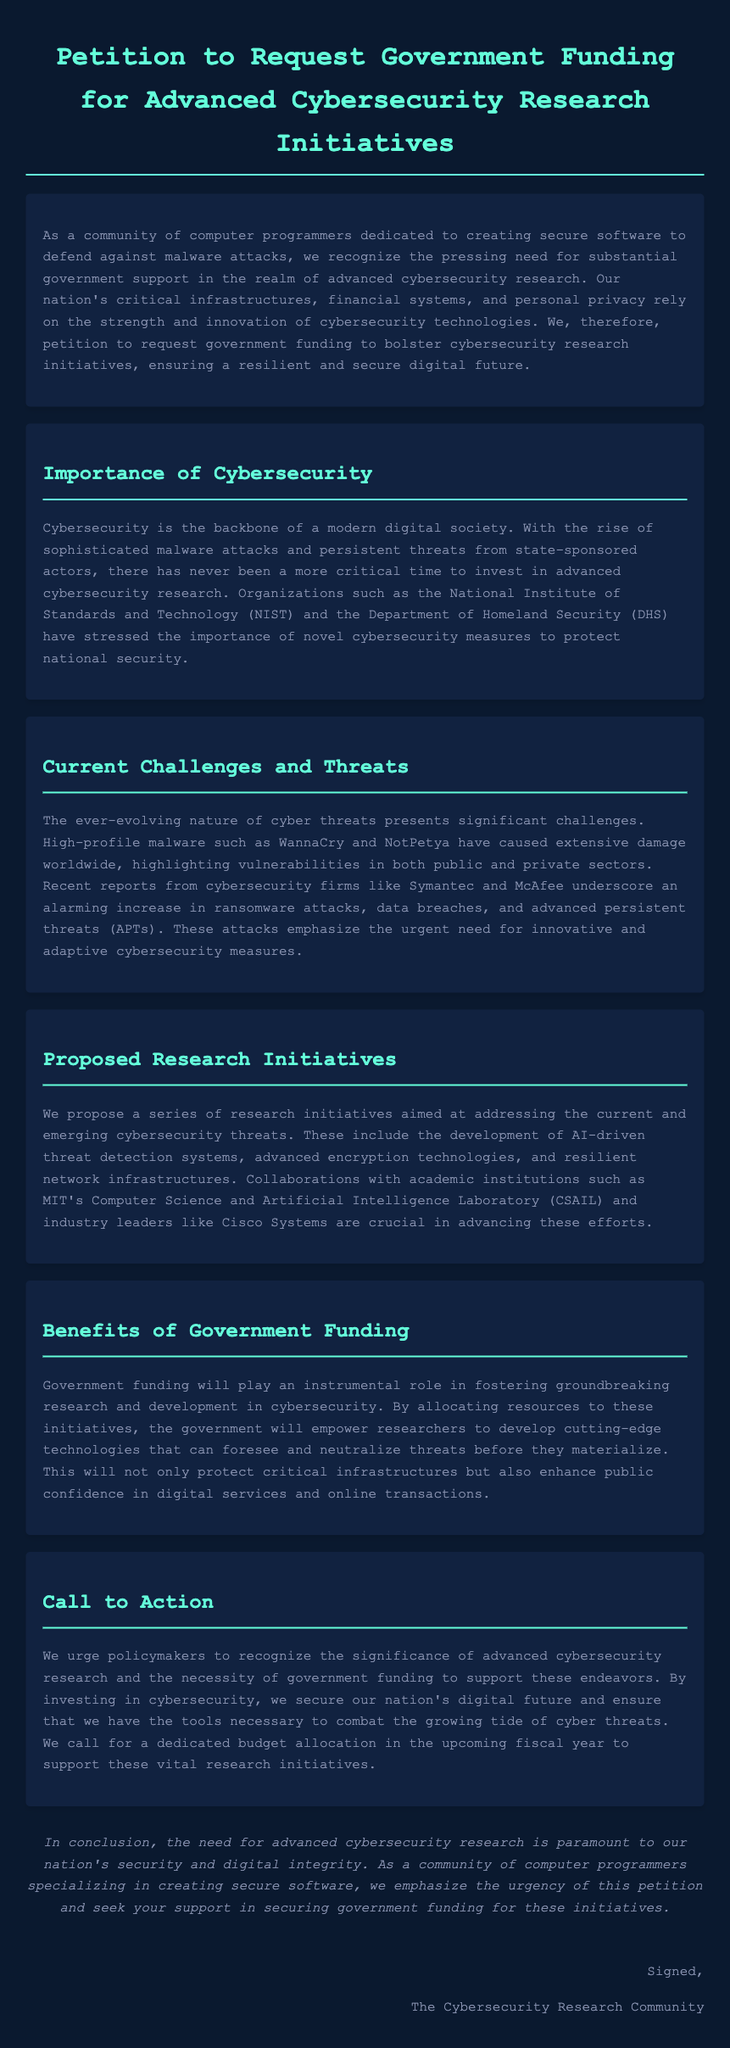What is the title of the petition? The title of the petition is indicated at the top of the document.
Answer: Petition to Request Government Funding for Advanced Cybersecurity Research Initiatives What organization emphasizes the importance of novel cybersecurity measures? The document mentions organizations that have stressed the importance of cybersecurity measures.
Answer: National Institute of Standards and Technology (NIST) What type of advanced technology is proposed for research initiatives? The proposed initiatives include specific advanced technologies mentioned in the document.
Answer: AI-driven threat detection systems Which malware attacks are highlighted as significant threats? The document lists high-profile malware that have caused damage and are noted as examples.
Answer: WannaCry and NotPetya What type of funding is being requested from the government? The petition specifically outlines the kind of financial support being sought.
Answer: Government funding How does the document describe the current state of cyber threats? The document provides context about the nature of cyber threats in today's digital environment.
Answer: Ever-evolving nature of cyber threats What is the call to action in the document? The document includes a specific request directed at policymakers regarding government funding.
Answer: Recognize the significance of advanced cybersecurity research Who is signing the petition? The document concludes by identifying the group representing the petitioners.
Answer: The Cybersecurity Research Community 